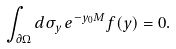<formula> <loc_0><loc_0><loc_500><loc_500>\int _ { \partial \Omega } d \sigma _ { y } \, e ^ { - y _ { 0 } M } f ( y ) = 0 .</formula> 